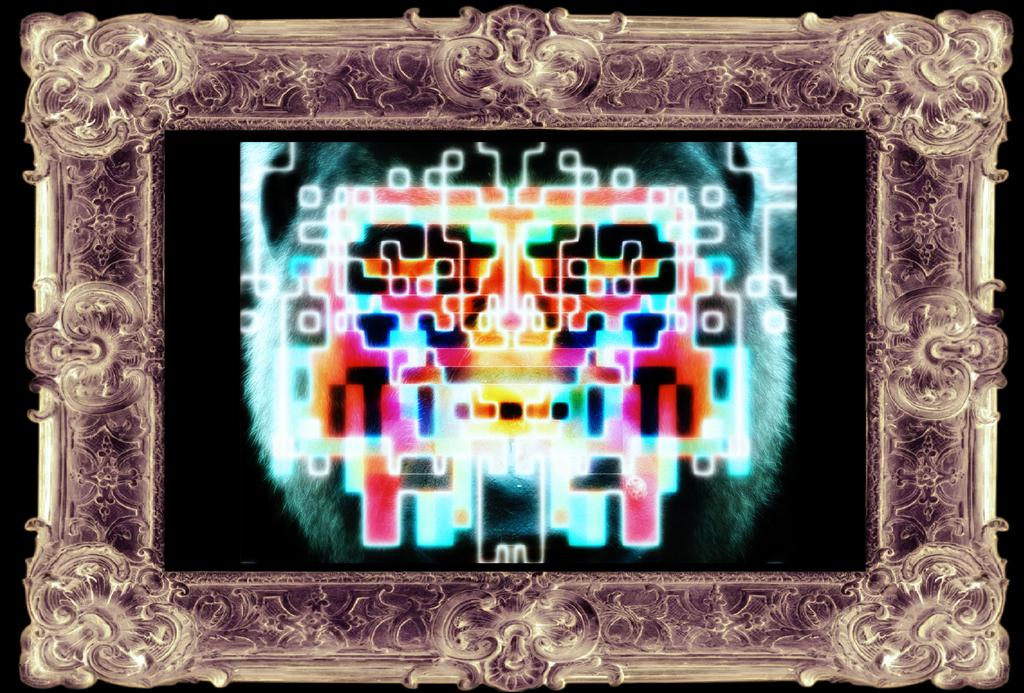What is the main object in the image? There is a frame in the image. What is inside the frame? The frame contains a structure. Can you describe the appearance of the structure? The structure has different colors in it. What does the grandmother say in the caption of the image? There is no caption or grandmother present in the image. 